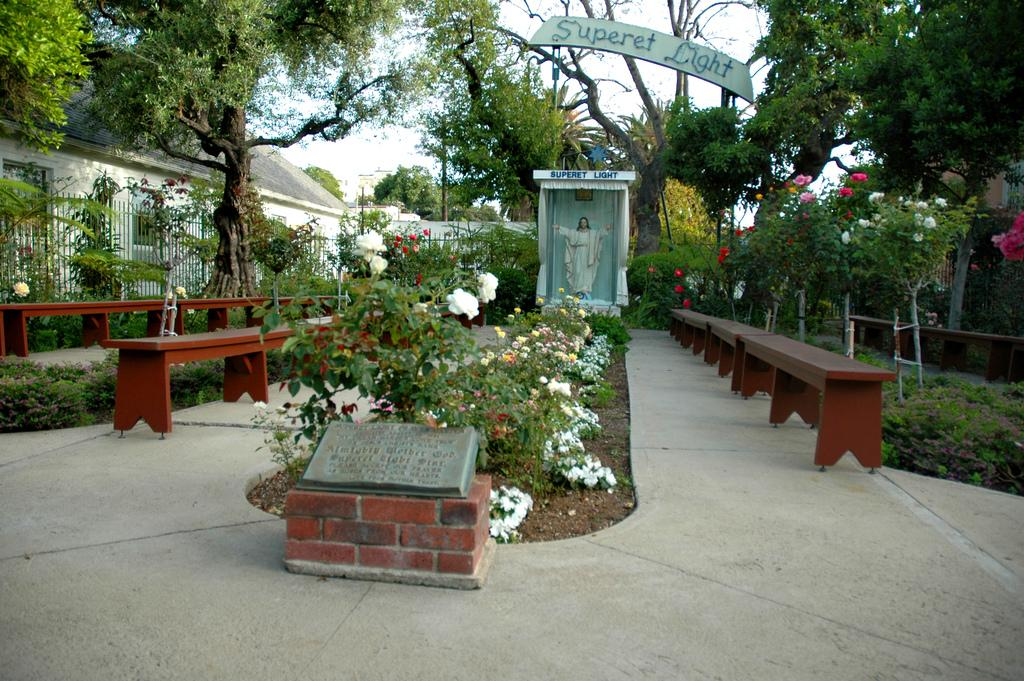What types of objects can be seen in the foreground area of the image? In the foreground area of the image, there are plants, wooden benches, a statue, a headstone, and boundaries. What is the statue of in the image? The facts provided do not specify what the statue is of. What can be seen in the background of the image? In the background of the image, there are trees, a roof, and the sky. What type of club is being used to hit the quarter in the mouth in the image? There is no club, quarter, or mouth present in the image. 